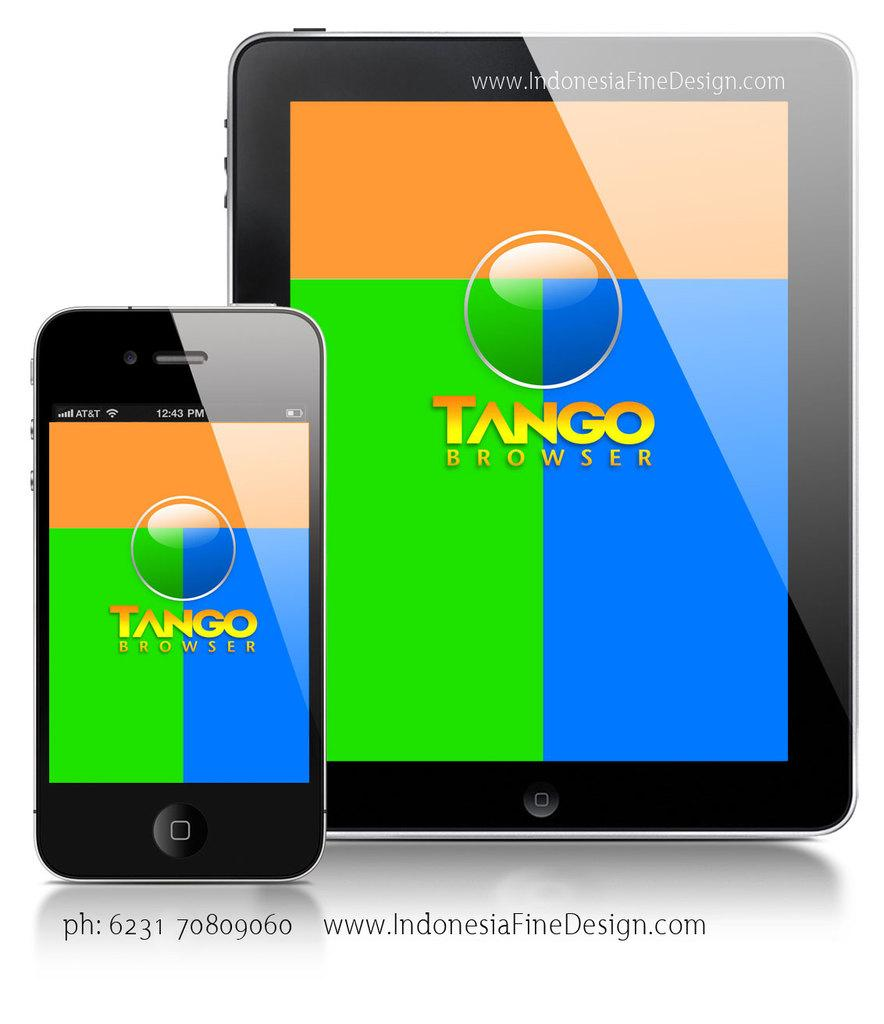<image>
Create a compact narrative representing the image presented. A phone showing the Tango Browser app is right next to a tablet showing the same app. 